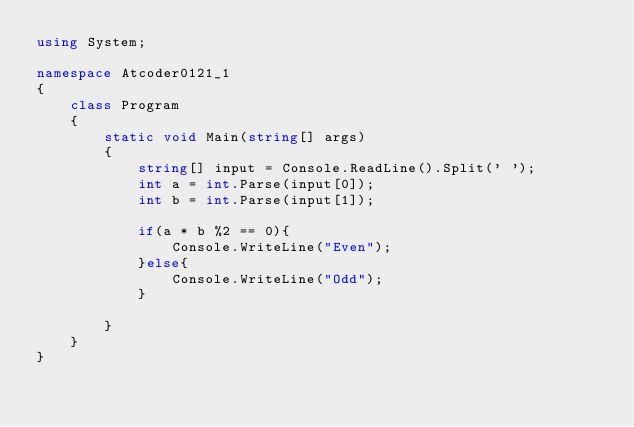Convert code to text. <code><loc_0><loc_0><loc_500><loc_500><_C#_>using System;

namespace Atcoder0121_1
{
    class Program
    {
        static void Main(string[] args)
        {
            string[] input = Console.ReadLine().Split(' ');
            int a = int.Parse(input[0]);
            int b = int.Parse(input[1]);

            if(a * b %2 == 0){
                Console.WriteLine("Even");
            }else{
                Console.WriteLine("Odd");
            }

        }
    }
}</code> 